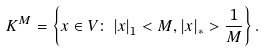Convert formula to latex. <formula><loc_0><loc_0><loc_500><loc_500>K ^ { M } = \left \{ x \in V \colon \left | x \right | _ { 1 } < M , \left | x \right | _ { \ast } > \frac { 1 } { M } \right \} .</formula> 